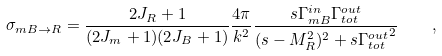<formula> <loc_0><loc_0><loc_500><loc_500>\sigma _ { m B \to R } = \frac { 2 J _ { R } + 1 } { ( 2 J _ { m } + 1 ) ( 2 J _ { B } + 1 ) } \frac { 4 \pi } { k ^ { 2 } } \frac { s \Gamma ^ { i n } _ { m B } \Gamma ^ { o u t } _ { t o t } } { ( s - M _ { R } ^ { 2 } ) ^ { 2 } + s { \Gamma ^ { o u t } _ { t o t } } ^ { 2 } } \quad ,</formula> 